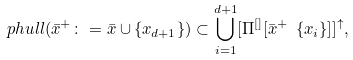Convert formula to latex. <formula><loc_0><loc_0><loc_500><loc_500>\ p h u l l ( \bar { x } ^ { + } \colon = \bar { x } \cup \{ x _ { d + 1 } \} ) \subset \bigcup _ { i = 1 } ^ { d + 1 } [ \Pi ^ { [ ] } [ \bar { x } ^ { + } \ \{ x _ { i } \} ] ] ^ { \uparrow } ,</formula> 